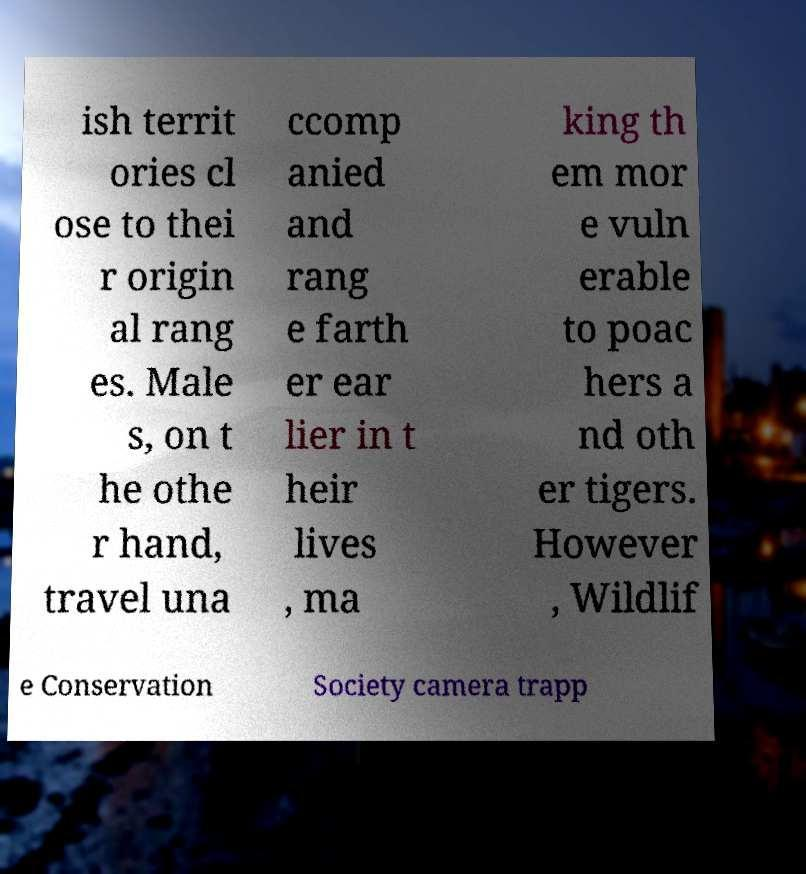What messages or text are displayed in this image? I need them in a readable, typed format. ish territ ories cl ose to thei r origin al rang es. Male s, on t he othe r hand, travel una ccomp anied and rang e farth er ear lier in t heir lives , ma king th em mor e vuln erable to poac hers a nd oth er tigers. However , Wildlif e Conservation Society camera trapp 